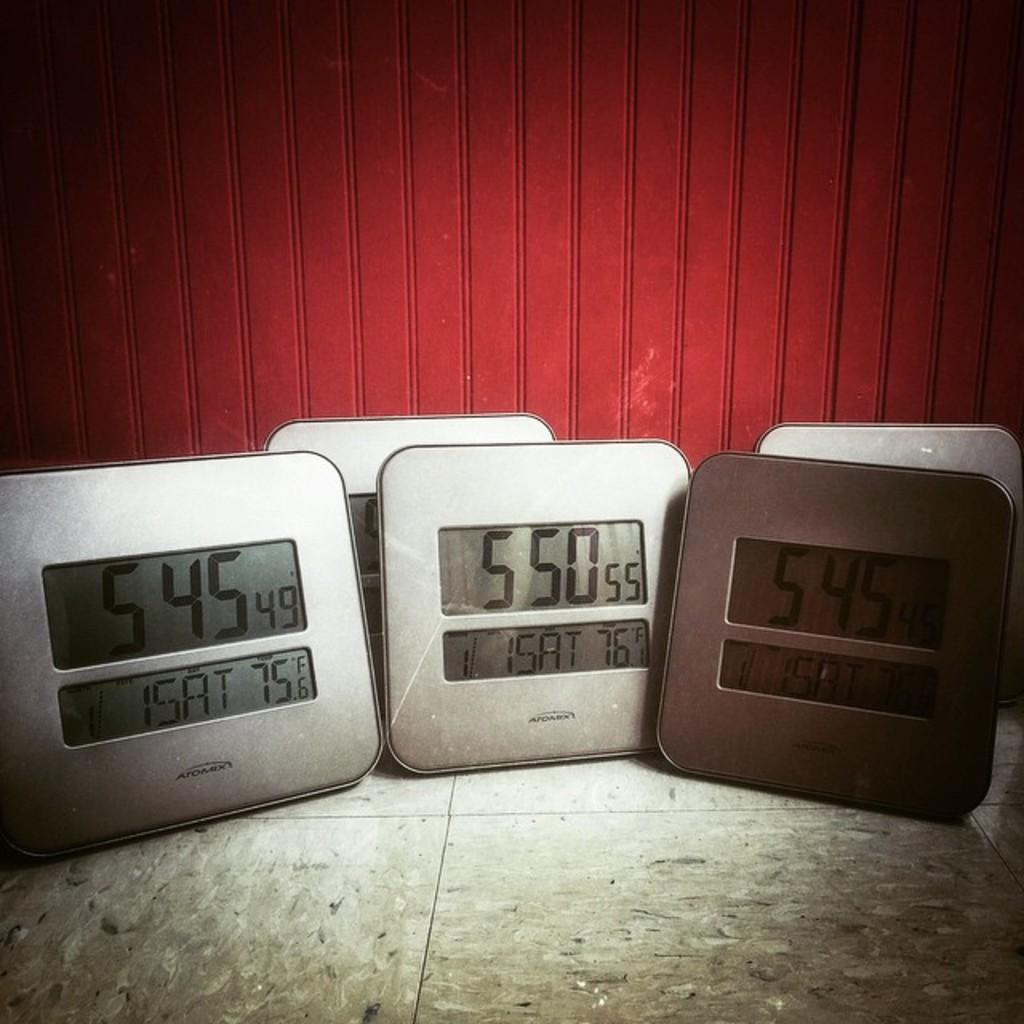What day of the week is it?
Provide a short and direct response. Saturday. What time is it, according to the clock on the left?
Your response must be concise. 5:45. 